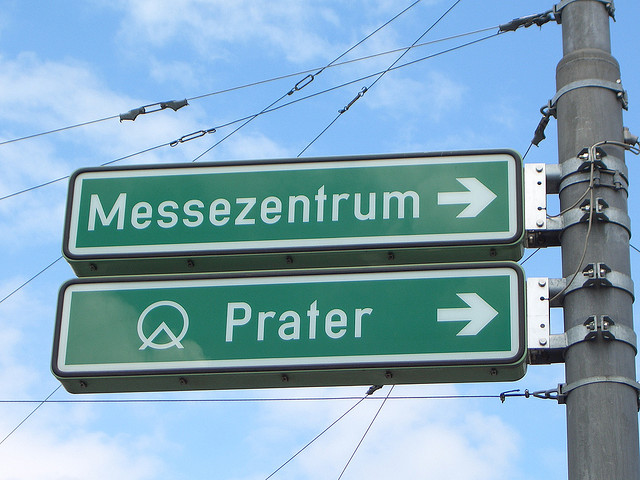<image>What are the wires in the sky? It is unknown what the wires in the sky are. They could be electricity lines, utility lines or supports. What are the wires in the sky? I don't know what the wires in the sky are. It can be electrical wires, electricity lines, tower supports or power lines. 